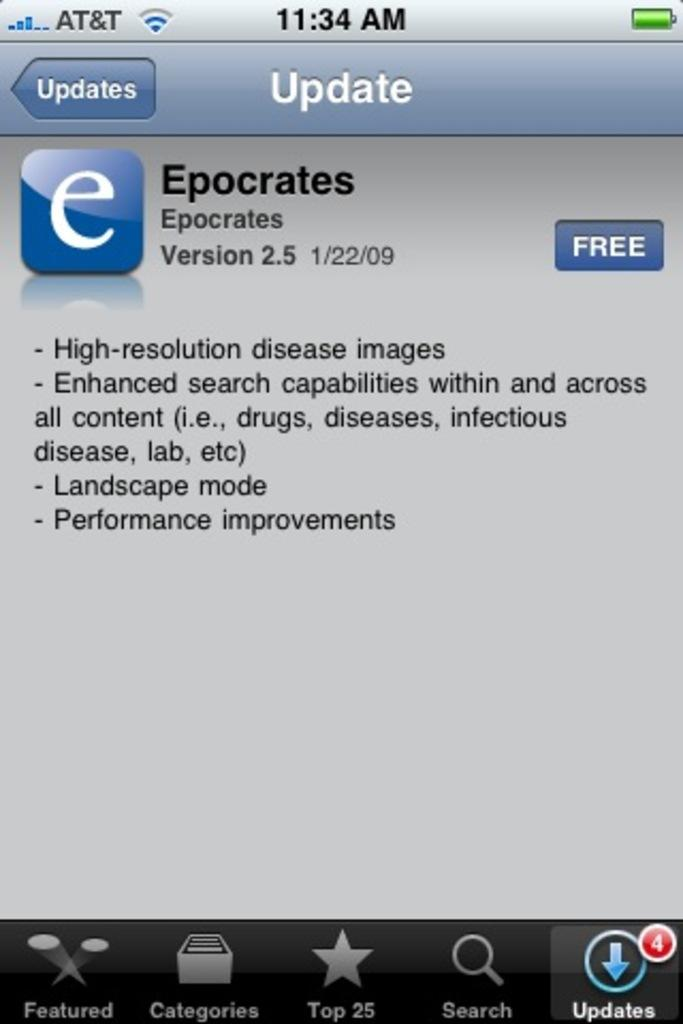Provide a one-sentence caption for the provided image. an AT&T phones is open to Epocrates app. 